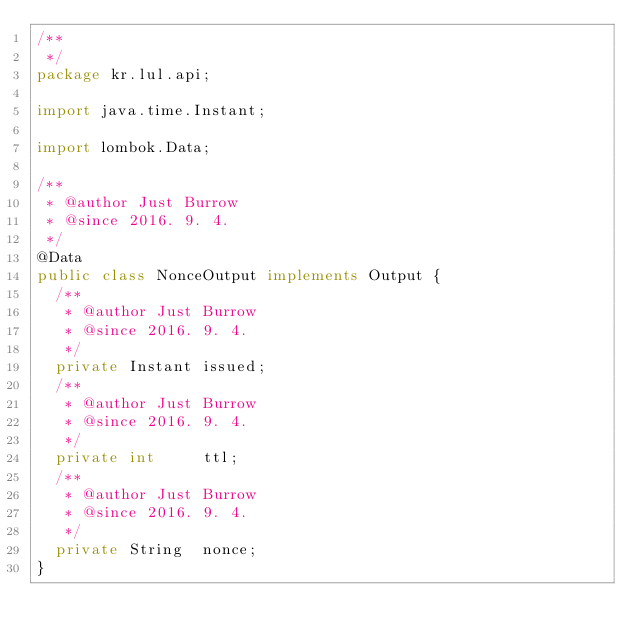Convert code to text. <code><loc_0><loc_0><loc_500><loc_500><_Java_>/**
 */
package kr.lul.api;

import java.time.Instant;

import lombok.Data;

/**
 * @author Just Burrow
 * @since 2016. 9. 4.
 */
@Data
public class NonceOutput implements Output {
  /**
   * @author Just Burrow
   * @since 2016. 9. 4.
   */
  private Instant issued;
  /**
   * @author Just Burrow
   * @since 2016. 9. 4.
   */
  private int     ttl;
  /**
   * @author Just Burrow
   * @since 2016. 9. 4.
   */
  private String  nonce;
}
</code> 